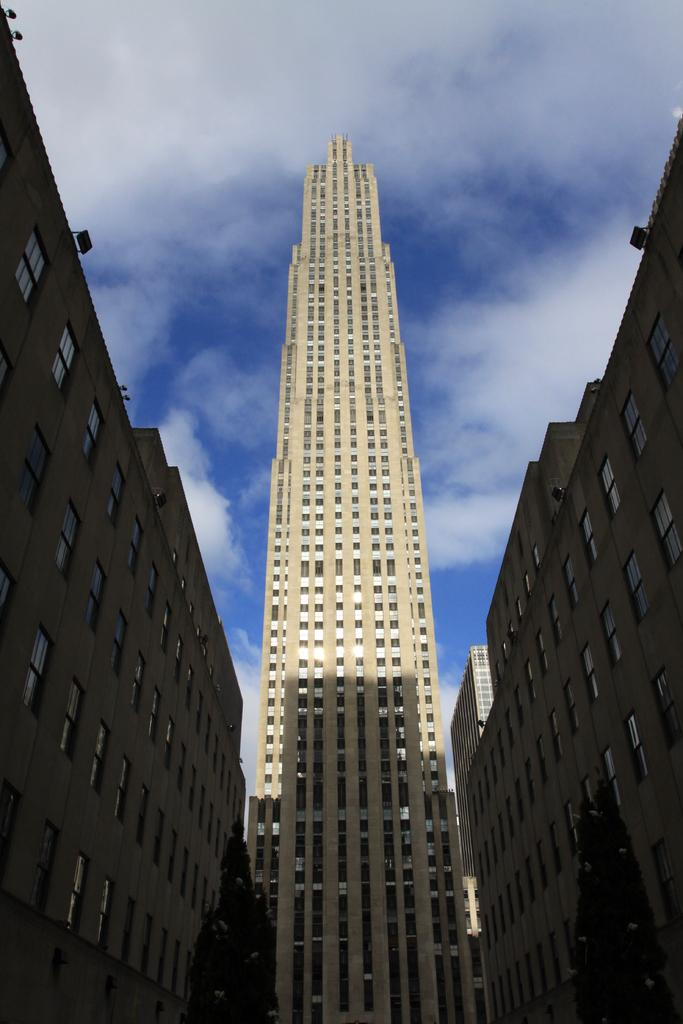What type of structures are present in the image? There are buildings in the image. What color are the buildings? The buildings are cream in color. What other elements can be seen in the image besides the buildings? There are trees in the image. What feature do the buildings have? The buildings have windows. What can be seen in the background of the image? The sky is visible in the background of the image. How many ducks can be seen swimming in the fountain in the image? There are no ducks or fountain present in the image; it features buildings, trees, and the sky. What color is the eye of the person in the image? There is no person present in the image, so it is not possible to determine the color of their eye. 